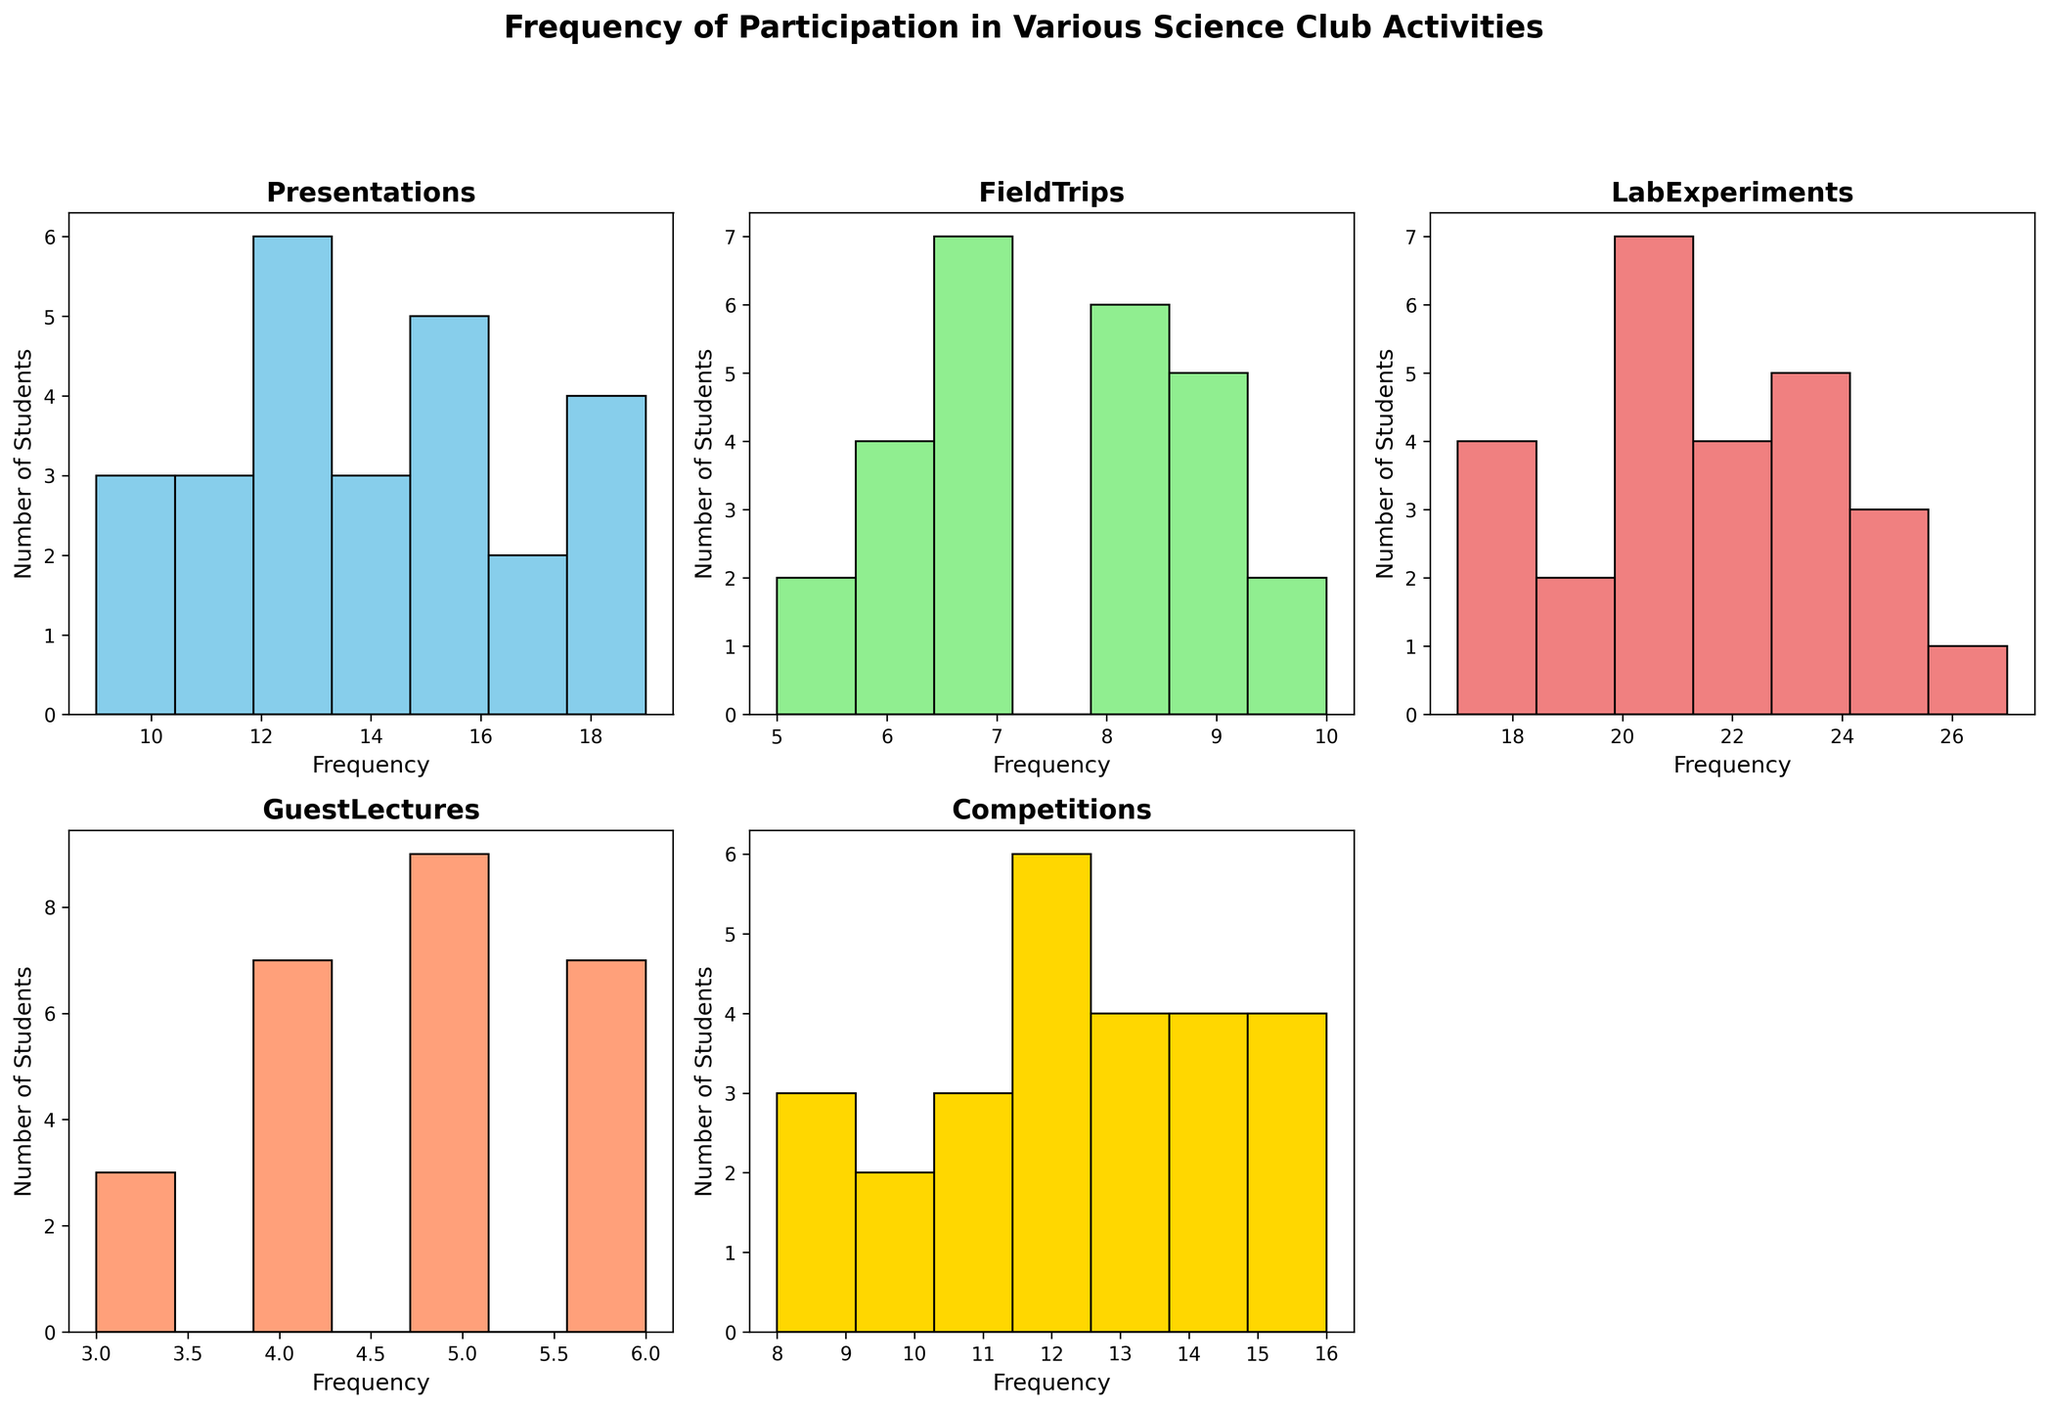What is the highest frequency of any student presentation? To find this, look for the tallest bar in the Presentations histogram. The highest frequency corresponds to the value at the top of this bar.
Answer: 19 How many students participated in 10 lab experiments? Look at the bar for frequency 10 in the Lab Experiments histogram and note its height, which represents the number of students.
Answer: 0 In which activity did the most students participate 8 times? Compare the height of bars for frequency 8 across all histograms. The tallest bar will indicate the activity with the most number of students participating 8 times.
Answer: FieldTrips What is the average frequency of students attending guest lectures? To find this, sum all the frequencies of Guest Lectures, then divide by the number of students. Sum: (5+3+4+6+5+4+5+6+3+5+4+5+6+4+5+6+3+5+4+3+6+4+5+6) = 117, Number of students = 26, Average = 117/26.
Answer: 4.5 How does participation in field trips compare to competitions for frequency 9? Look at the bars for frequency 9 in Field Trips and Competitions histograms. Compare their heights to see which is taller.
Answer: Competitions is higher Are the heights of bars for 20 and 25 lab experiments the same? Compare the heights of the bars for frequencies 20 and 25 in the Lab Experiments histogram. If they reach the same level, they are the same height.
Answer: No Which activity has the most uniform distribution of participation? Evaluate the histograms and identify which histogram has bars of relatively similar heights, indicating a uniform distribution.
Answer: LabExperiments How does the participation in presentations differ between the highest and the lowest frequency? Identify the highest and the lowest bars in the Presentations histogram, then calculate the difference in their heights.
Answer: Height difference represents difference in participation Which activity had the least frequent guest lectures attended per student on average? Calculate the average frequency for each activity and compare them. The activity with the lowest average frequency had the least frequent attendance.
Answer: GuestLectures How many more students attended 14 presentations compared to 10 guest lectures? Look at the bars for 14 in Presentations and for 10 in Guest Lectures, note their heights, and subtract the height of the 10 Guest Lectures bar from the 14 Presentations bar.
Answer: 0 